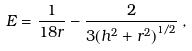Convert formula to latex. <formula><loc_0><loc_0><loc_500><loc_500>E = \frac { 1 } { 1 8 r } - \frac { 2 } { 3 { \left ( h ^ { 2 } + r ^ { 2 } \right ) } ^ { 1 / 2 } } \, ,</formula> 